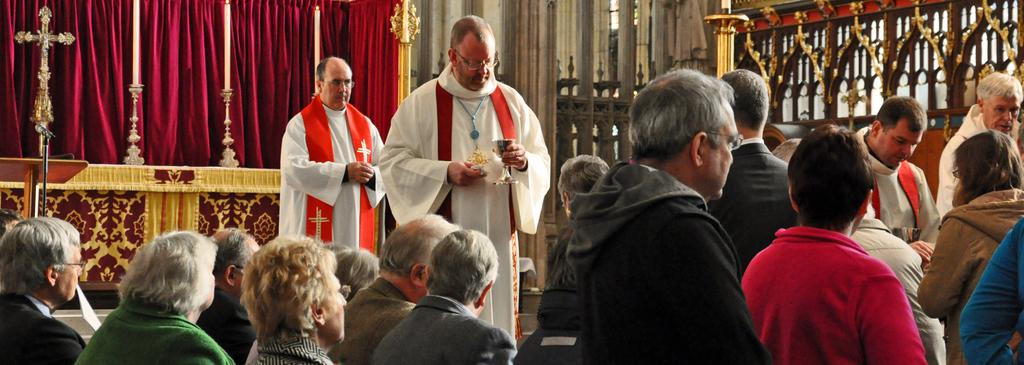How many people are in the image? There is a group of people in the image. What is the man holding in his hand? The man is holding a glass with his hand. What can be seen in the background of the image? In the background of the image, there is a mic, a cross, curtains, candles on candle stands, and some other objects. Can you see a mailbox in the image? There is no mailbox present in the image. Are there any airplanes or docks visible in the image? No, there are no airplanes or docks present in the image. 